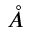Convert formula to latex. <formula><loc_0><loc_0><loc_500><loc_500>\mathring { A }</formula> 